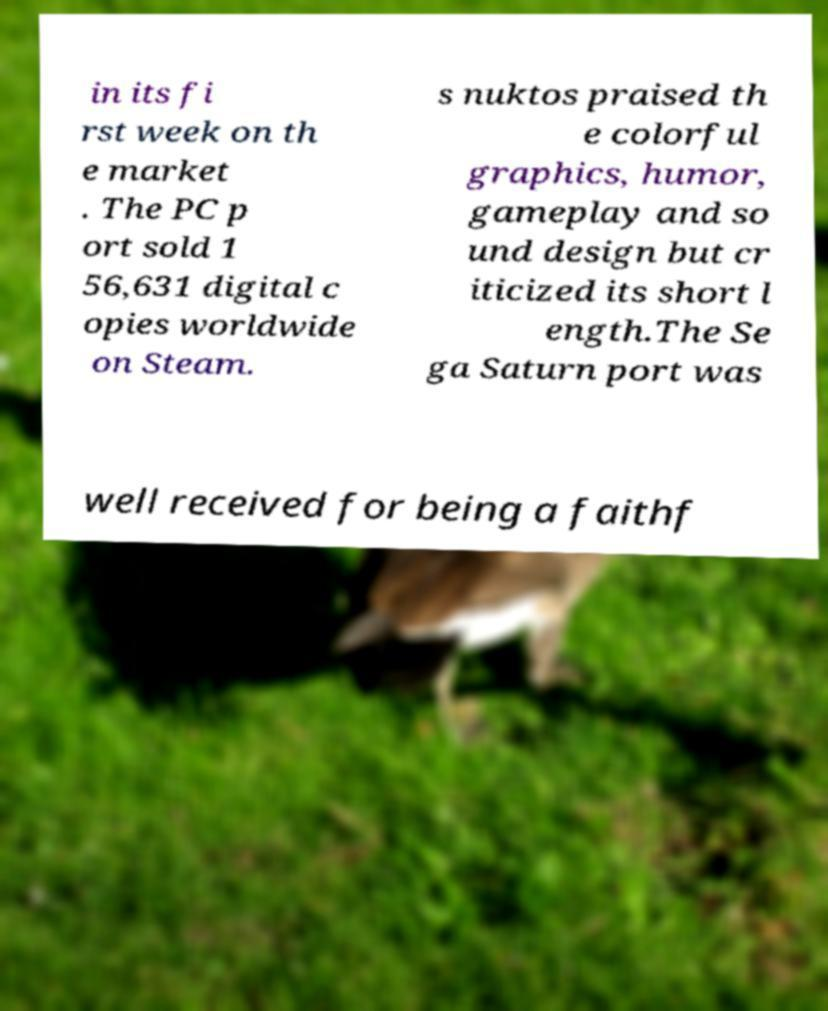I need the written content from this picture converted into text. Can you do that? in its fi rst week on th e market . The PC p ort sold 1 56,631 digital c opies worldwide on Steam. s nuktos praised th e colorful graphics, humor, gameplay and so und design but cr iticized its short l ength.The Se ga Saturn port was well received for being a faithf 